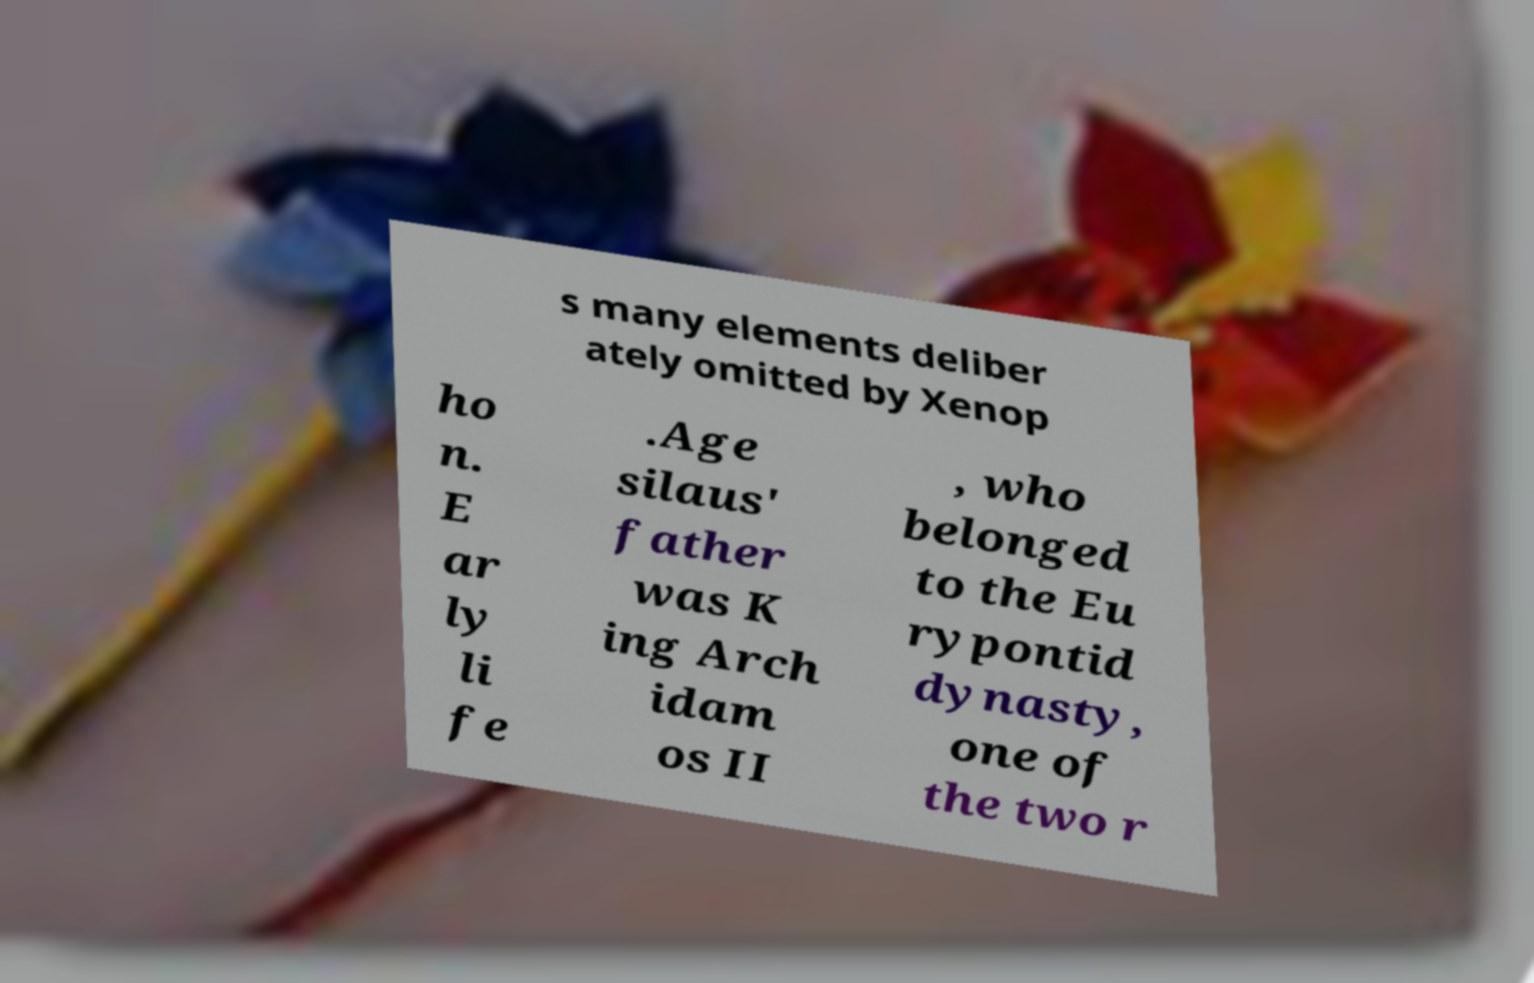Please identify and transcribe the text found in this image. s many elements deliber ately omitted by Xenop ho n. E ar ly li fe .Age silaus' father was K ing Arch idam os II , who belonged to the Eu rypontid dynasty, one of the two r 